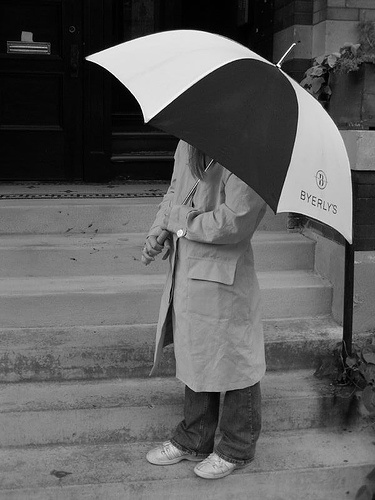Describe the objects in this image and their specific colors. I can see people in black, gray, and lightgray tones and umbrella in black, lightgray, darkgray, and gray tones in this image. 